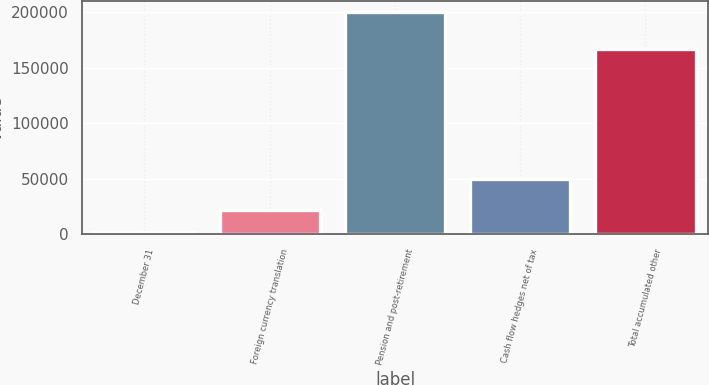Convert chart to OTSL. <chart><loc_0><loc_0><loc_500><loc_500><bar_chart><fcel>December 31<fcel>Foreign currency translation<fcel>Pension and post-retirement<fcel>Cash flow hedges net of tax<fcel>Total accumulated other<nl><fcel>2013<fcel>21775.1<fcel>199634<fcel>49897<fcel>166567<nl></chart> 